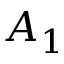<formula> <loc_0><loc_0><loc_500><loc_500>A _ { 1 }</formula> 